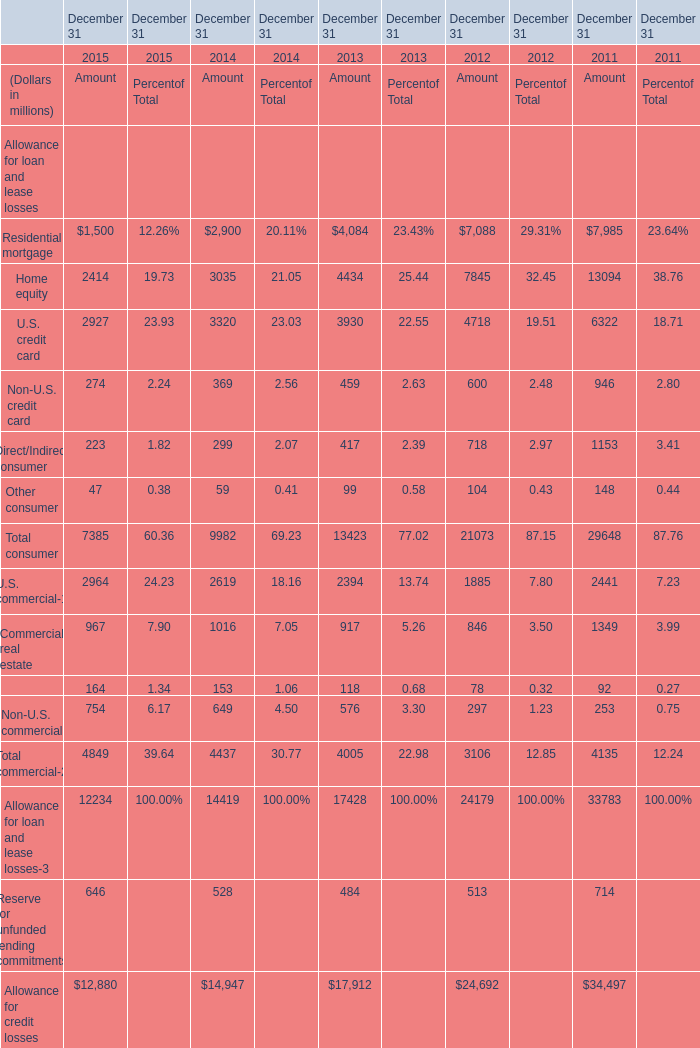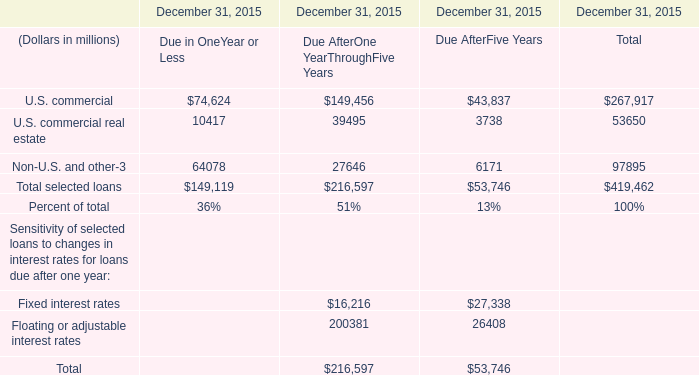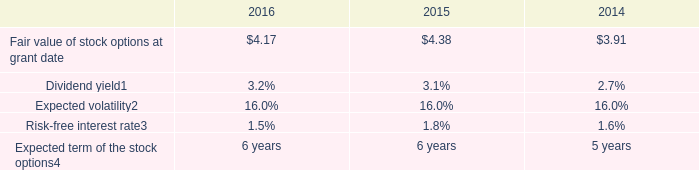What is the growing rate of Home equity of Amount in Table 0 in the years with the least Dividend yield in Table 2? 
Computations: ((3035 - 4434) / 4434)
Answer: -0.31552. 